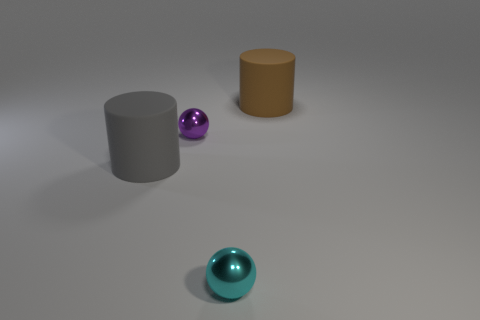There is a purple thing that is the same size as the cyan thing; what material is it?
Your answer should be compact. Metal. There is a brown rubber thing; is its size the same as the ball in front of the gray cylinder?
Make the answer very short. No. How many rubber things are tiny gray things or gray objects?
Keep it short and to the point. 1. How many small cyan metal objects are the same shape as the purple metal object?
Ensure brevity in your answer.  1. There is a rubber cylinder that is left of the big brown rubber thing; is its size the same as the purple shiny sphere behind the big gray thing?
Provide a succinct answer. No. What is the shape of the metallic thing behind the large gray rubber cylinder?
Keep it short and to the point. Sphere. There is a gray object that is the same shape as the brown object; what is its material?
Provide a short and direct response. Rubber. Is the size of the matte cylinder left of the cyan shiny ball the same as the large brown matte object?
Offer a terse response. Yes. How many gray matte cylinders are behind the gray thing?
Give a very brief answer. 0. Are there fewer large brown matte cylinders in front of the purple metallic ball than brown matte cylinders that are in front of the gray matte cylinder?
Give a very brief answer. No. 